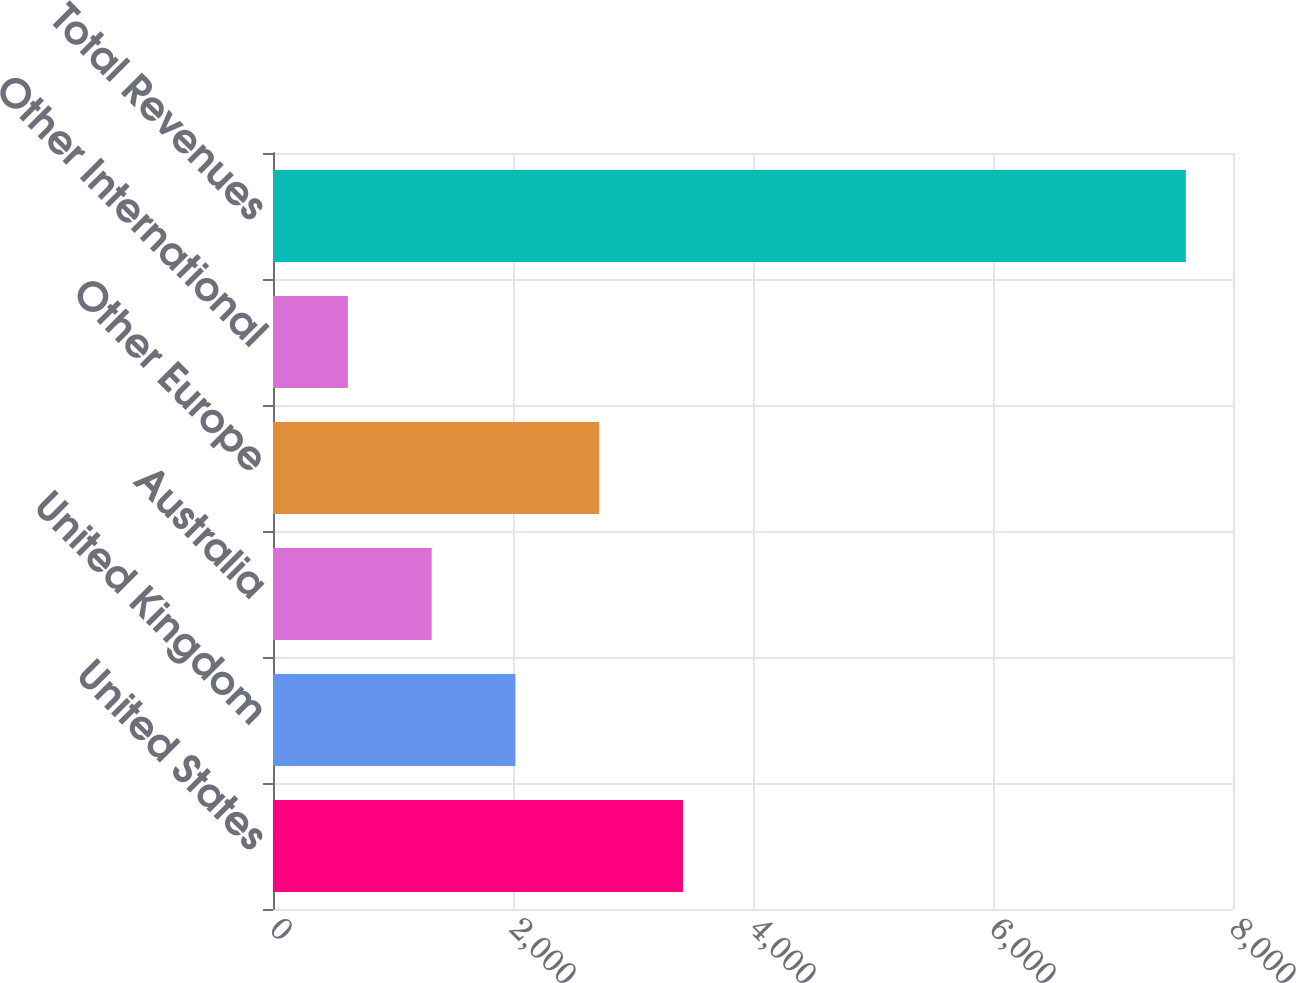Convert chart. <chart><loc_0><loc_0><loc_500><loc_500><bar_chart><fcel>United States<fcel>United Kingdom<fcel>Australia<fcel>Other Europe<fcel>Other International<fcel>Total Revenues<nl><fcel>3417.2<fcel>2020.6<fcel>1322.3<fcel>2718.9<fcel>624<fcel>7607<nl></chart> 